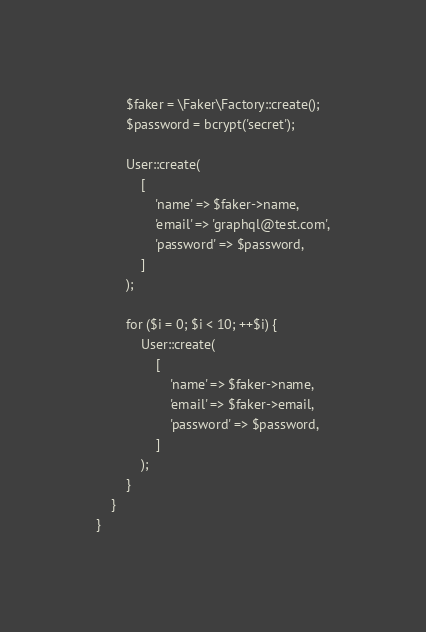<code> <loc_0><loc_0><loc_500><loc_500><_PHP_>
        $faker = \Faker\Factory::create();
        $password = bcrypt('secret');

        User::create(
            [
                'name' => $faker->name,
                'email' => 'graphql@test.com',
                'password' => $password,
            ]
        );

        for ($i = 0; $i < 10; ++$i) {
            User::create(
                [
                    'name' => $faker->name,
                    'email' => $faker->email,
                    'password' => $password,
                ]
            );
        }
    }
}
</code> 